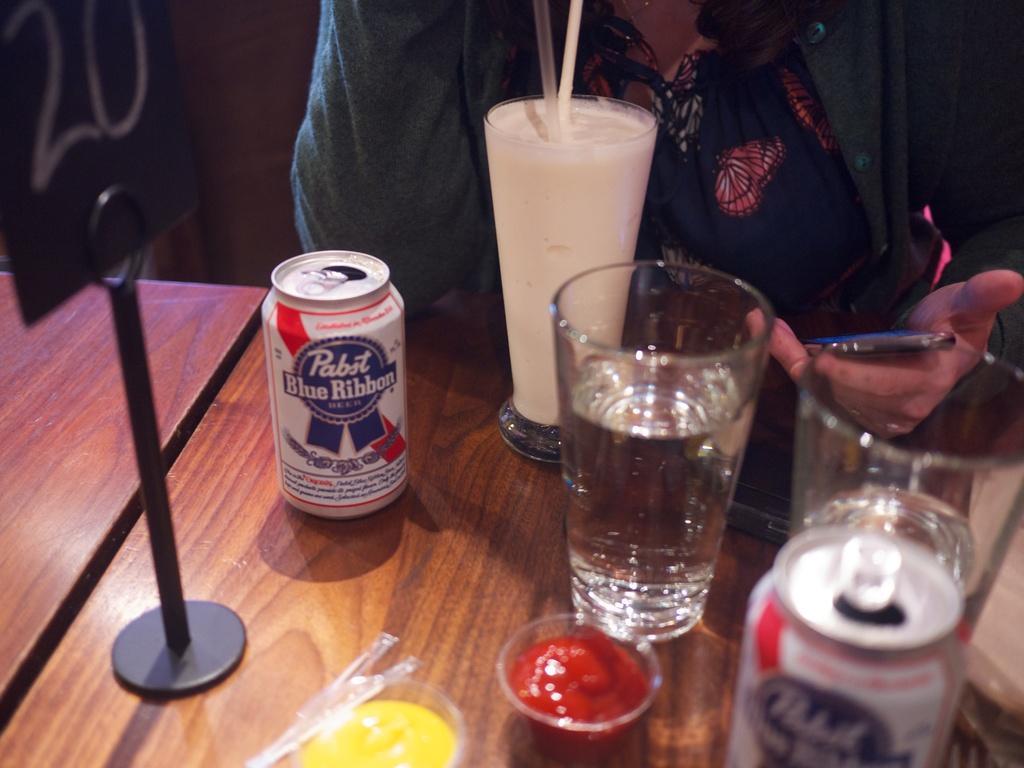Describe this image in one or two sentences. In this picture I can see tins, glasses with liquids in it, there are straws in a glass, there are food items in bowls and there is a board on the table, and in the background there is a person holding an object. 